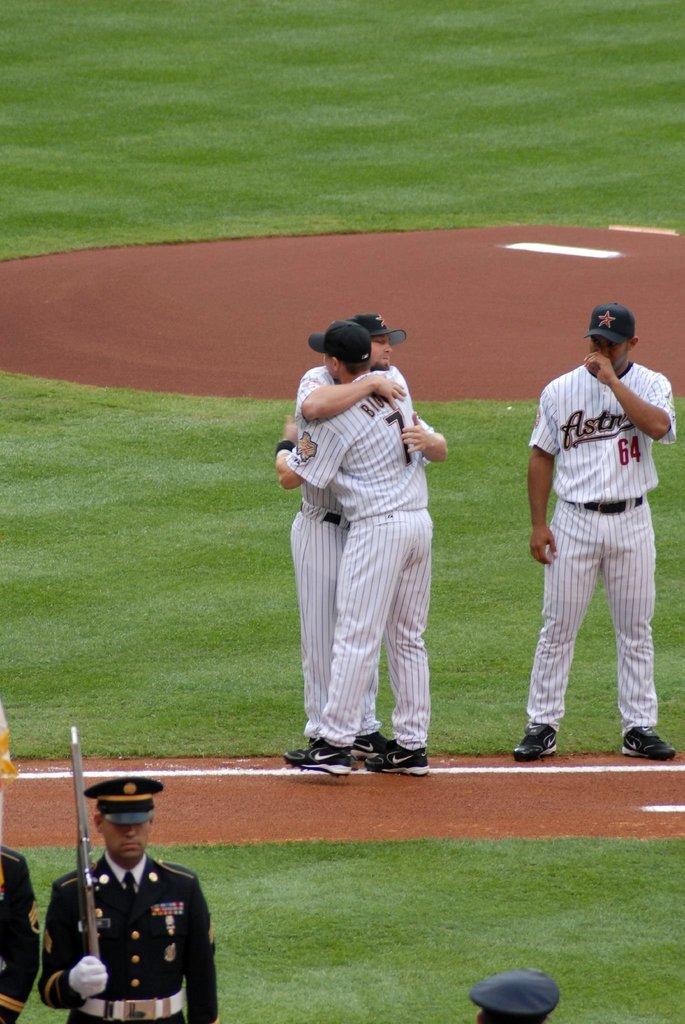Could you give a brief overview of what you see in this image? In the center of the image we can see two men standing in the ground hugging each other. We can also see a group of people around them. In that a man wearing a cap is holding a gun. We can also see some grass on the ground. 